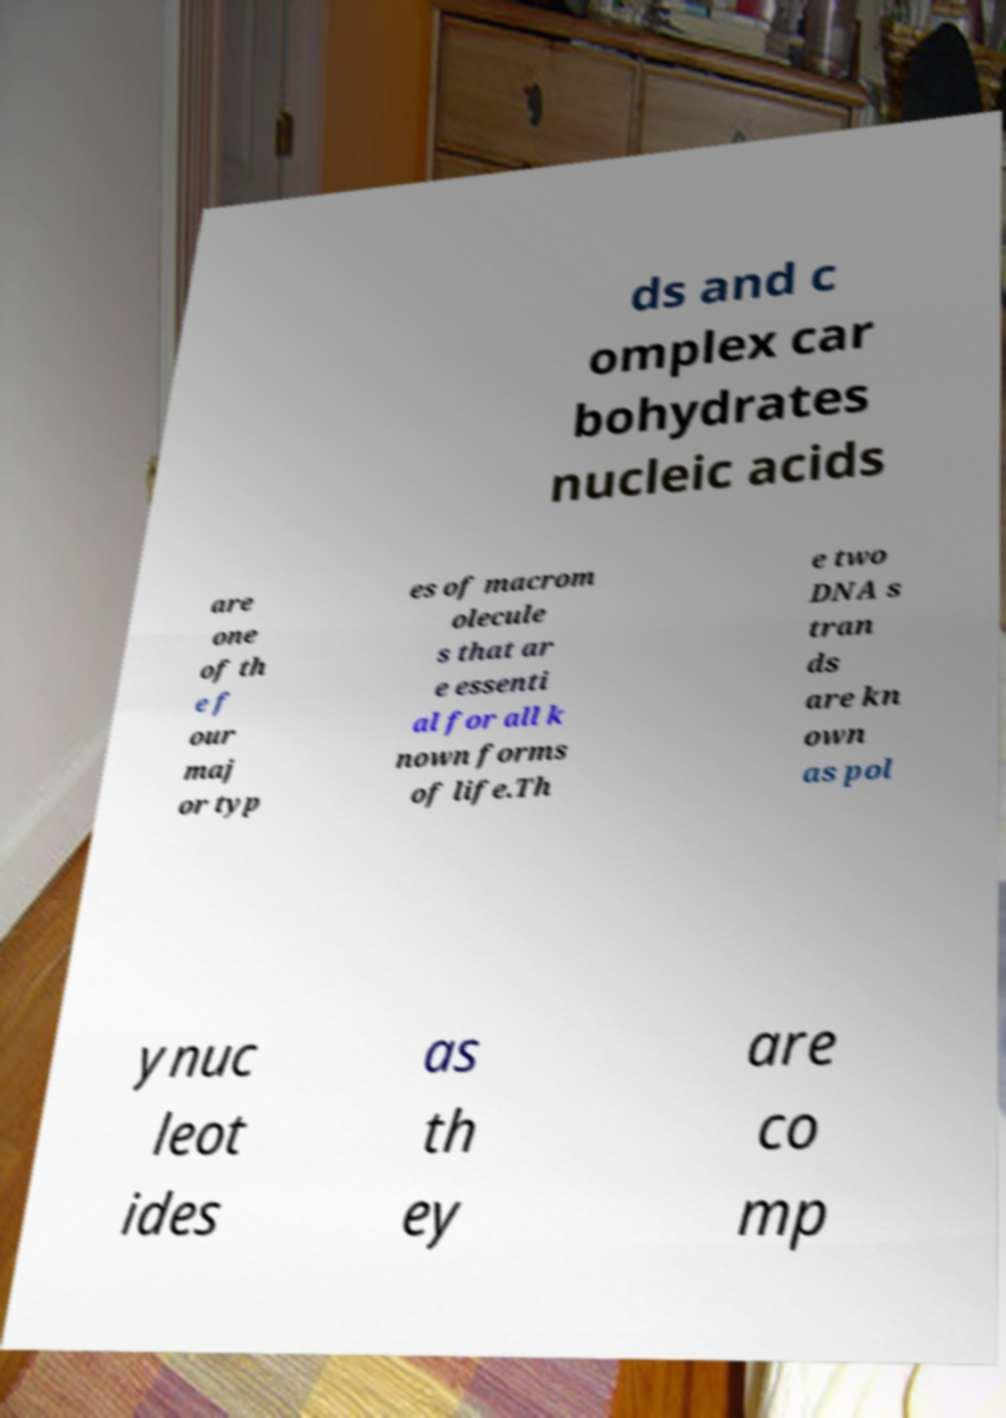There's text embedded in this image that I need extracted. Can you transcribe it verbatim? ds and c omplex car bohydrates nucleic acids are one of th e f our maj or typ es of macrom olecule s that ar e essenti al for all k nown forms of life.Th e two DNA s tran ds are kn own as pol ynuc leot ides as th ey are co mp 